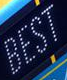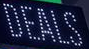Transcribe the words shown in these images in order, separated by a semicolon. BEST; DEALS 